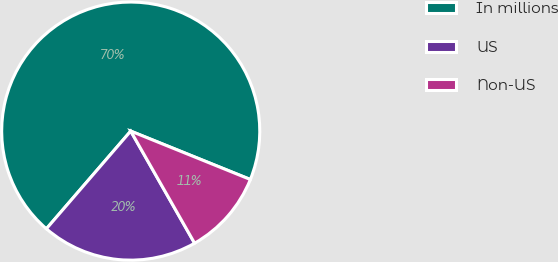Convert chart to OTSL. <chart><loc_0><loc_0><loc_500><loc_500><pie_chart><fcel>In millions<fcel>US<fcel>Non-US<nl><fcel>69.79%<fcel>19.58%<fcel>10.64%<nl></chart> 